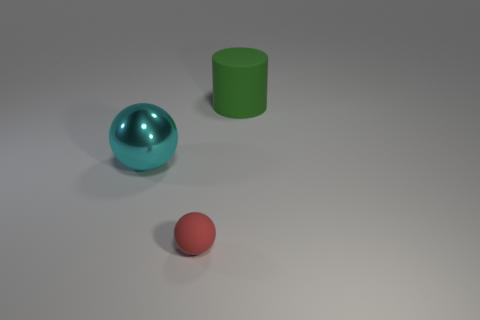Add 3 big yellow rubber cylinders. How many objects exist? 6 Subtract all spheres. How many objects are left? 1 Add 2 green matte cylinders. How many green matte cylinders exist? 3 Subtract 0 yellow spheres. How many objects are left? 3 Subtract all large objects. Subtract all big green objects. How many objects are left? 0 Add 1 tiny red objects. How many tiny red objects are left? 2 